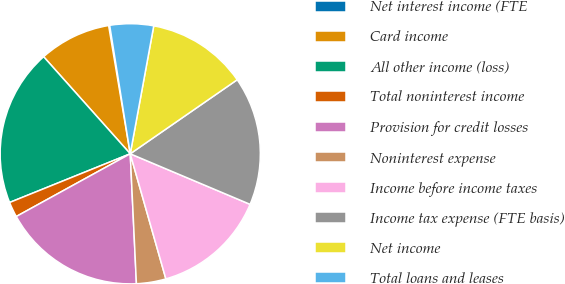Convert chart to OTSL. <chart><loc_0><loc_0><loc_500><loc_500><pie_chart><fcel>Net interest income (FTE<fcel>Card income<fcel>All other income (loss)<fcel>Total noninterest income<fcel>Provision for credit losses<fcel>Noninterest expense<fcel>Income before income taxes<fcel>Income tax expense (FTE basis)<fcel>Net income<fcel>Total loans and leases<nl><fcel>0.13%<fcel>8.94%<fcel>19.51%<fcel>1.9%<fcel>17.75%<fcel>3.66%<fcel>14.23%<fcel>15.99%<fcel>12.47%<fcel>5.42%<nl></chart> 